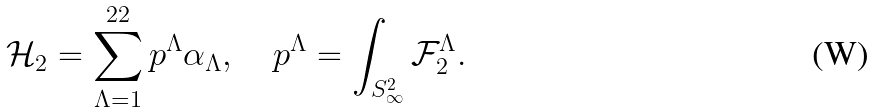Convert formula to latex. <formula><loc_0><loc_0><loc_500><loc_500>\mathcal { H } _ { 2 } = \sum _ { \Lambda = 1 } ^ { 2 2 } p ^ { \Lambda } \alpha _ { \Lambda } , \quad p ^ { \Lambda } = \int _ { S _ { \infty } ^ { 2 } } \mathcal { F } _ { 2 } ^ { \Lambda } .</formula> 